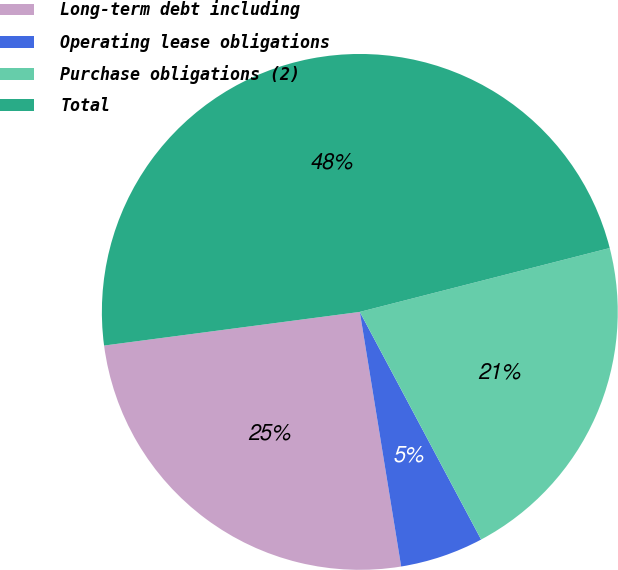Convert chart to OTSL. <chart><loc_0><loc_0><loc_500><loc_500><pie_chart><fcel>Long-term debt including<fcel>Operating lease obligations<fcel>Purchase obligations (2)<fcel>Total<nl><fcel>25.48%<fcel>5.23%<fcel>21.19%<fcel>48.1%<nl></chart> 